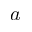Convert formula to latex. <formula><loc_0><loc_0><loc_500><loc_500>a</formula> 